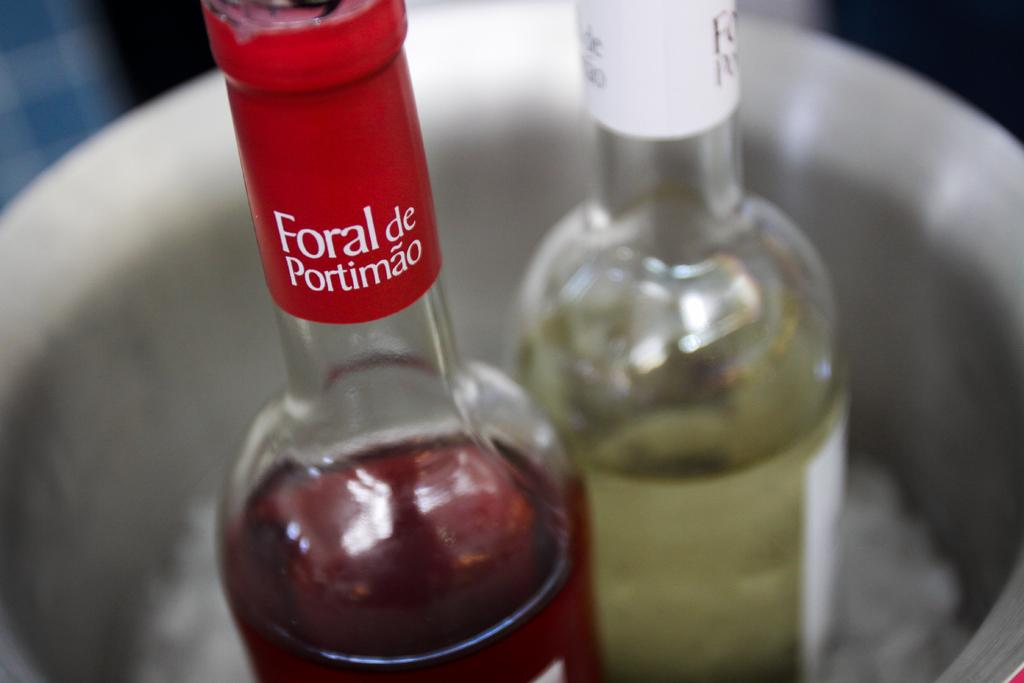<image>
Present a compact description of the photo's key features. Bottle with a red label that says Foral de Portimao. 